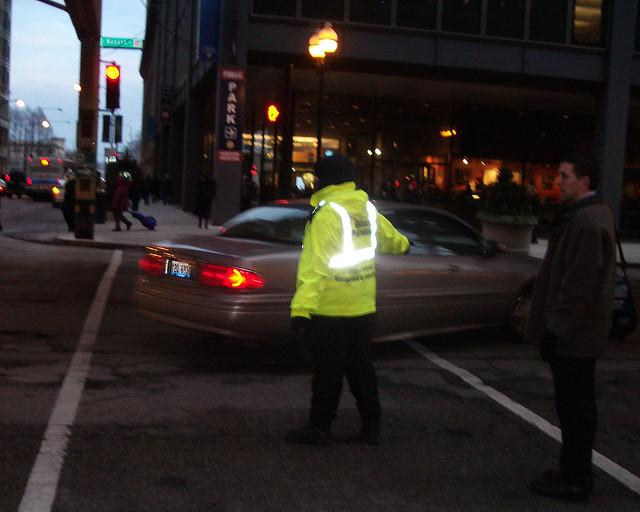Why is the man wearing a reflective jacket?

Choices:
A) visibility
B) on team
C) fashion
D) received free visibility 